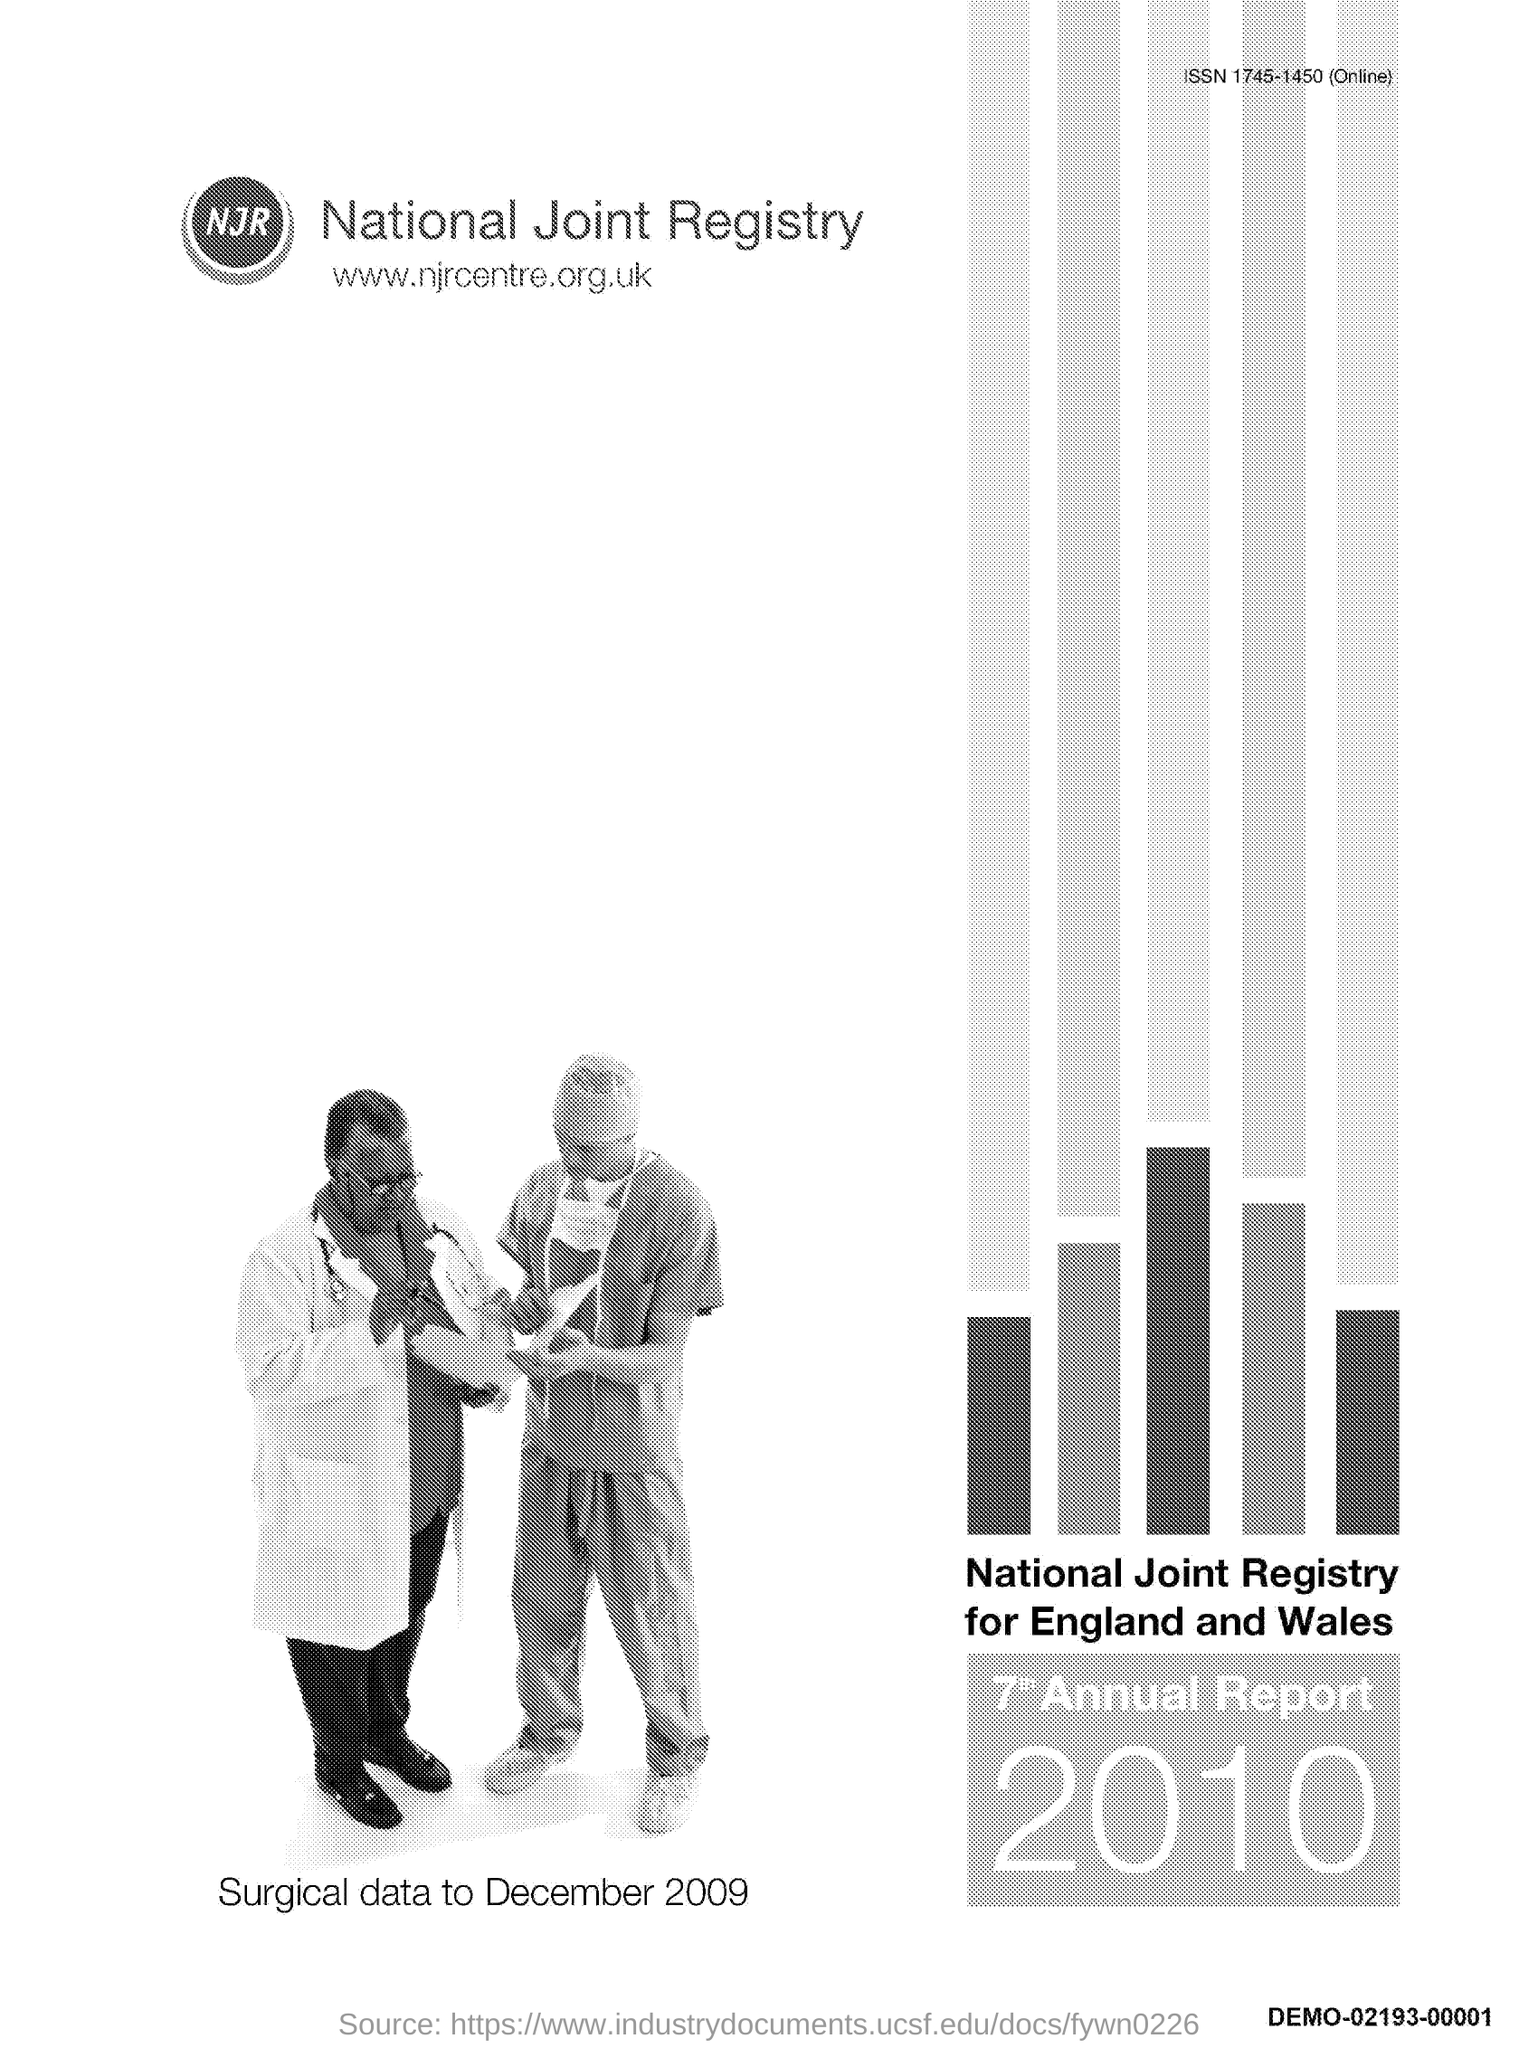Highlight a few significant elements in this photo. The website address is [www.njrcentre.org.uk](http://www.njrcentre.org.uk). The ISSN code for the publication is 1745-1450. The report in question was generated in the year 2010. 